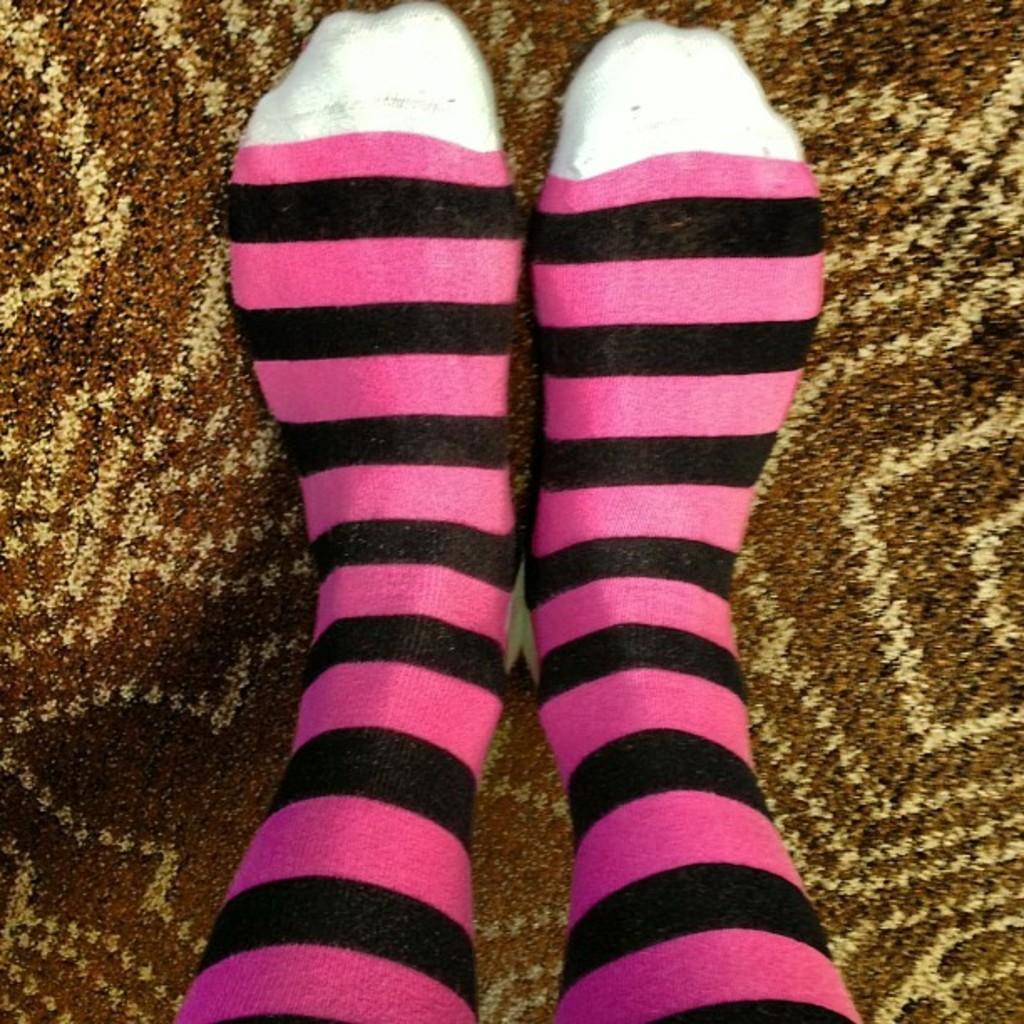Could you give a brief overview of what you see in this image? In this image we can see the legs of a person. 